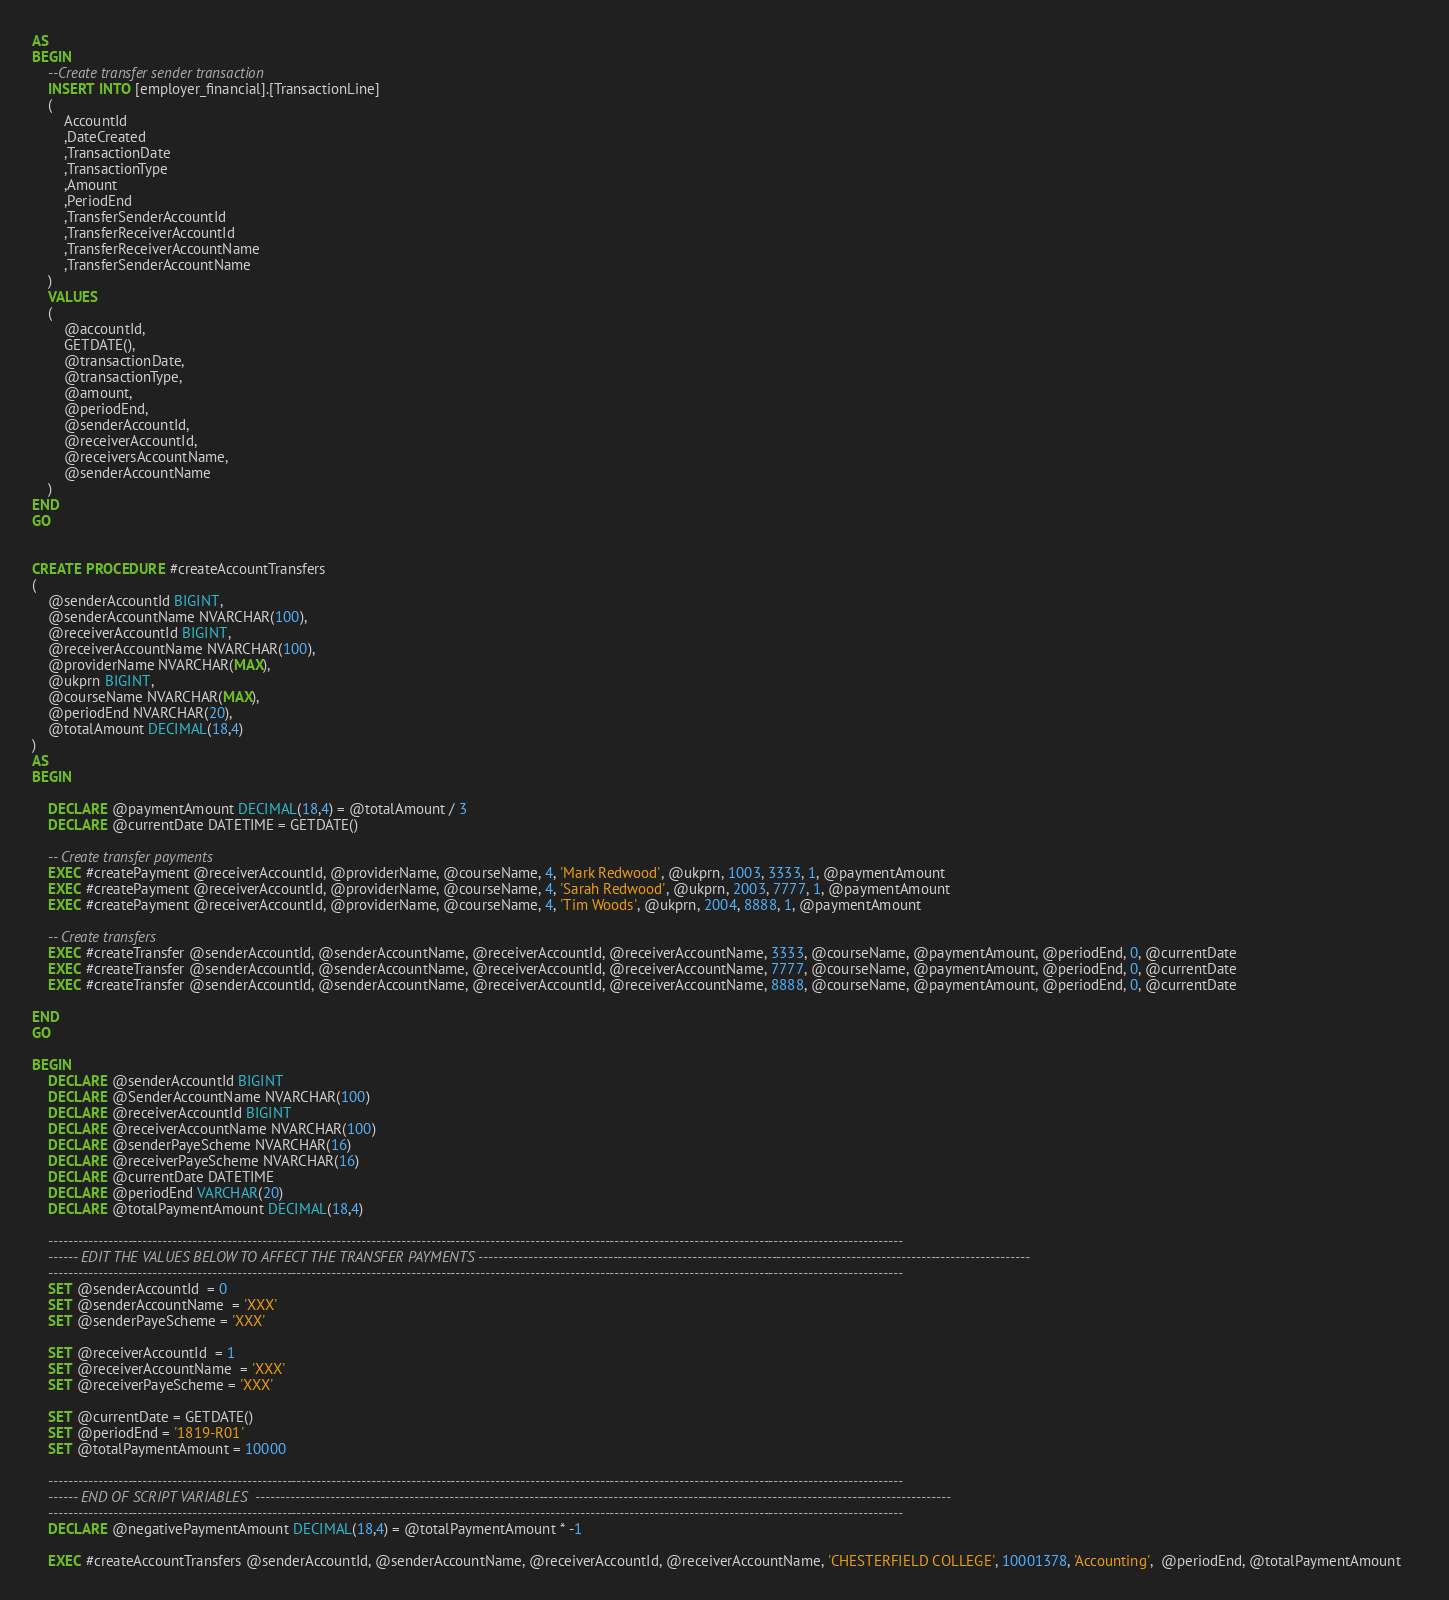Convert code to text. <code><loc_0><loc_0><loc_500><loc_500><_SQL_>AS	
BEGIN
	--Create transfer sender transaction
	INSERT INTO [employer_financial].[TransactionLine]
	(
		AccountId
		,DateCreated 		
		,TransactionDate 
		,TransactionType 
		,Amount 		
		,PeriodEnd 		
		,TransferSenderAccountId
		,TransferReceiverAccountId
		,TransferReceiverAccountName		
		,TransferSenderAccountName
	)
	VALUES
	(
		@accountId,
		GETDATE(),
		@transactionDate,
		@transactionType,
		@amount,
		@periodEnd,
		@senderAccountId,
		@receiverAccountId,
		@receiversAccountName,
		@senderAccountName
	)
END
GO


CREATE PROCEDURE #createAccountTransfers
(     
	@senderAccountId BIGINT,
	@senderAccountName NVARCHAR(100),
	@receiverAccountId BIGINT,
	@receiverAccountName NVARCHAR(100),
	@providerName NVARCHAR(MAX),
	@ukprn BIGINT,
	@courseName NVARCHAR(MAX),
	@periodEnd NVARCHAR(20),
	@totalAmount DECIMAL(18,4)
)  
AS  
BEGIN  	

    DECLARE @paymentAmount DECIMAL(18,4) = @totalAmount / 3
	DECLARE @currentDate DATETIME = GETDATE()	

	-- Create transfer payments
	EXEC #createPayment @receiverAccountId, @providerName, @courseName, 4, 'Mark Redwood', @ukprn, 1003, 3333, 1, @paymentAmount
	EXEC #createPayment @receiverAccountId, @providerName, @courseName, 4, 'Sarah Redwood', @ukprn, 2003, 7777, 1, @paymentAmount 
	EXEC #createPayment @receiverAccountId, @providerName, @courseName, 4, 'Tim Woods', @ukprn, 2004, 8888, 1, @paymentAmount 

	-- Create transfers
	EXEC #createTransfer @senderAccountId, @senderAccountName, @receiverAccountId, @receiverAccountName, 3333, @courseName, @paymentAmount, @periodEnd, 0, @currentDate
	EXEC #createTransfer @senderAccountId, @senderAccountName, @receiverAccountId, @receiverAccountName, 7777, @courseName, @paymentAmount, @periodEnd, 0, @currentDate
	EXEC #createTransfer @senderAccountId, @senderAccountName, @receiverAccountId, @receiverAccountName, 8888, @courseName, @paymentAmount, @periodEnd, 0, @currentDate

END
GO

BEGIN
	DECLARE @senderAccountId BIGINT
	DECLARE @SenderAccountName NVARCHAR(100)
	DECLARE @receiverAccountId BIGINT
	DECLARE @receiverAccountName NVARCHAR(100)
	DECLARE @senderPayeScheme NVARCHAR(16)
	DECLARE @receiverPayeScheme NVARCHAR(16)
	DECLARE @currentDate DATETIME
    DECLARE @periodEnd VARCHAR(20)
    DECLARE @totalPaymentAmount DECIMAL(18,4)	

    ----------------------------------------------------------------------------------------------------------------------------------------------------------------------------
    ------ EDIT THE VALUES BELOW TO AFFECT THE TRANSFER PAYMENTS ---------------------------------------------------------------------------------------------------------------
    ----------------------------------------------------------------------------------------------------------------------------------------------------------------------------
	SET @senderAccountId  = 0
	SET @senderAccountName  = 'XXX'
	SET @senderPayeScheme = 'XXX'

    SET @receiverAccountId  = 1
	SET @receiverAccountName  = 'XXX'	
	SET @receiverPayeScheme = 'XXX'
	
    SET @currentDate = GETDATE()
    SET @periodEnd = '1819-R01'
    SET @totalPaymentAmount = 10000
	
    ----------------------------------------------------------------------------------------------------------------------------------------------------------------------------
    ------ END OF SCRIPT VARIABLES  --------------------------------------------------------------------------------------------------------------------------------------------
    ----------------------------------------------------------------------------------------------------------------------------------------------------------------------------
	DECLARE @negativePaymentAmount DECIMAL(18,4) = @totalPaymentAmount * -1

	EXEC #createAccountTransfers @senderAccountId, @senderAccountName, @receiverAccountId, @receiverAccountName, 'CHESTERFIELD COLLEGE', 10001378, 'Accounting',  @periodEnd, @totalPaymentAmount	</code> 